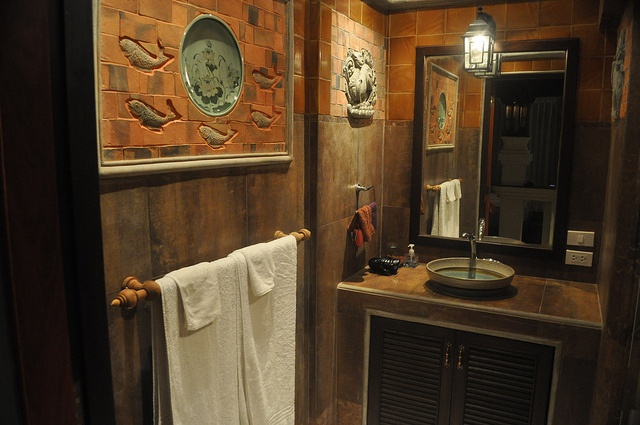Describe the objects in this image and their specific colors. I can see a sink in black and olive tones in this image. 